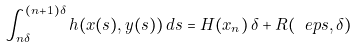Convert formula to latex. <formula><loc_0><loc_0><loc_500><loc_500>\int _ { n \delta } ^ { ( n + 1 ) \delta } h ( x ( s ) , y ( s ) ) \, d s = H ( x _ { n } ) \, \delta + R ( \ e p s , \delta )</formula> 